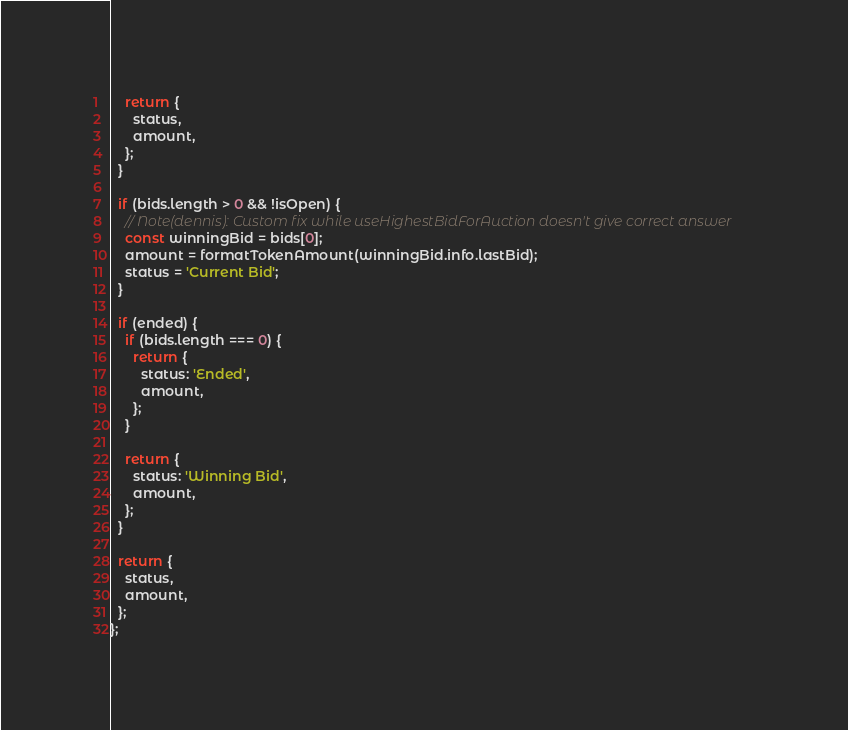Convert code to text. <code><loc_0><loc_0><loc_500><loc_500><_TypeScript_>
    return {
      status,
      amount,
    };
  }

  if (bids.length > 0 && !isOpen) {
    // Note(dennis): Custom fix while useHighestBidForAuction doesn't give correct answer
    const winningBid = bids[0];
    amount = formatTokenAmount(winningBid.info.lastBid);
    status = 'Current Bid';
  }

  if (ended) {
    if (bids.length === 0) {
      return {
        status: 'Ended',
        amount,
      };
    }

    return {
      status: 'Winning Bid',
      amount,
    };
  }

  return {
    status,
    amount,
  };
};
</code> 